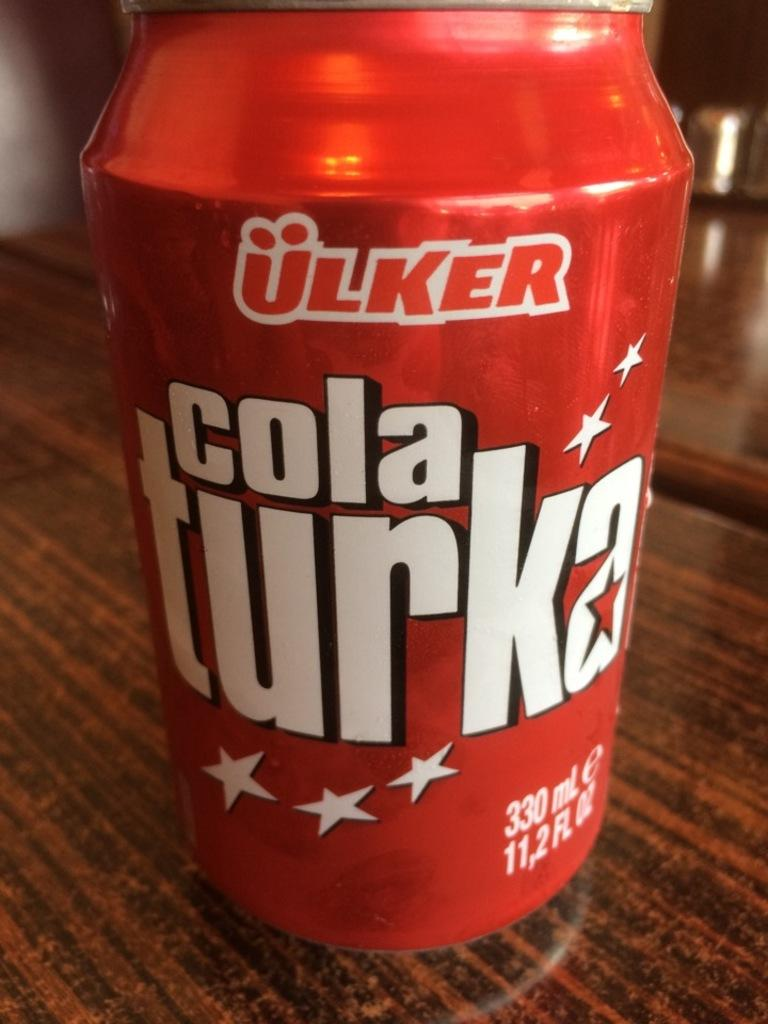<image>
Present a compact description of the photo's key features. A red can of Cola Turka is on a wooden surface. 